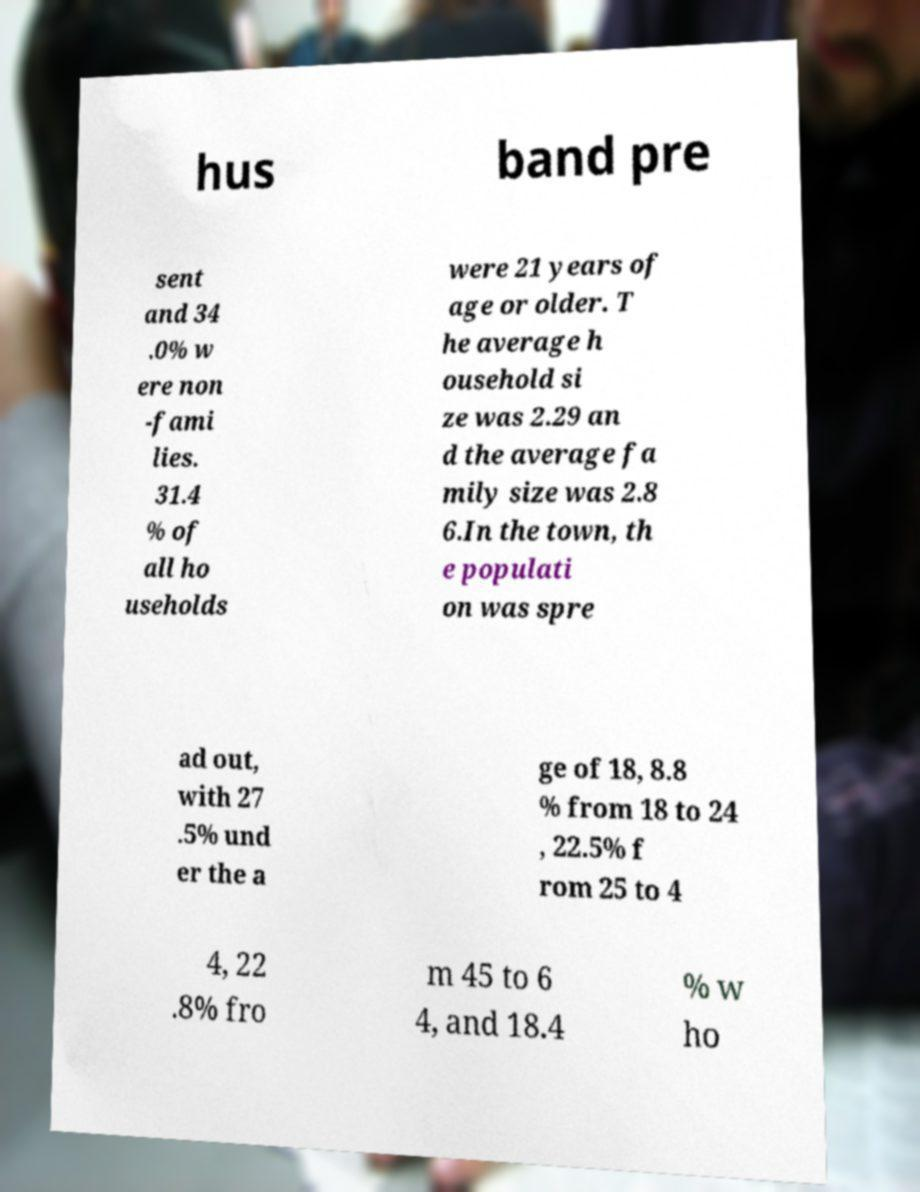Please read and relay the text visible in this image. What does it say? hus band pre sent and 34 .0% w ere non -fami lies. 31.4 % of all ho useholds were 21 years of age or older. T he average h ousehold si ze was 2.29 an d the average fa mily size was 2.8 6.In the town, th e populati on was spre ad out, with 27 .5% und er the a ge of 18, 8.8 % from 18 to 24 , 22.5% f rom 25 to 4 4, 22 .8% fro m 45 to 6 4, and 18.4 % w ho 